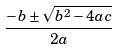<formula> <loc_0><loc_0><loc_500><loc_500>\frac { - b \pm \sqrt { b ^ { 2 } - 4 a c } } { 2 a }</formula> 